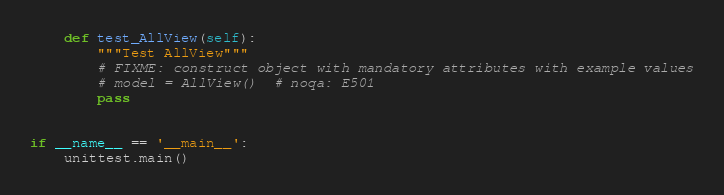Convert code to text. <code><loc_0><loc_0><loc_500><loc_500><_Python_>    def test_AllView(self):
        """Test AllView"""
        # FIXME: construct object with mandatory attributes with example values
        # model = AllView()  # noqa: E501
        pass


if __name__ == '__main__':
    unittest.main()
</code> 